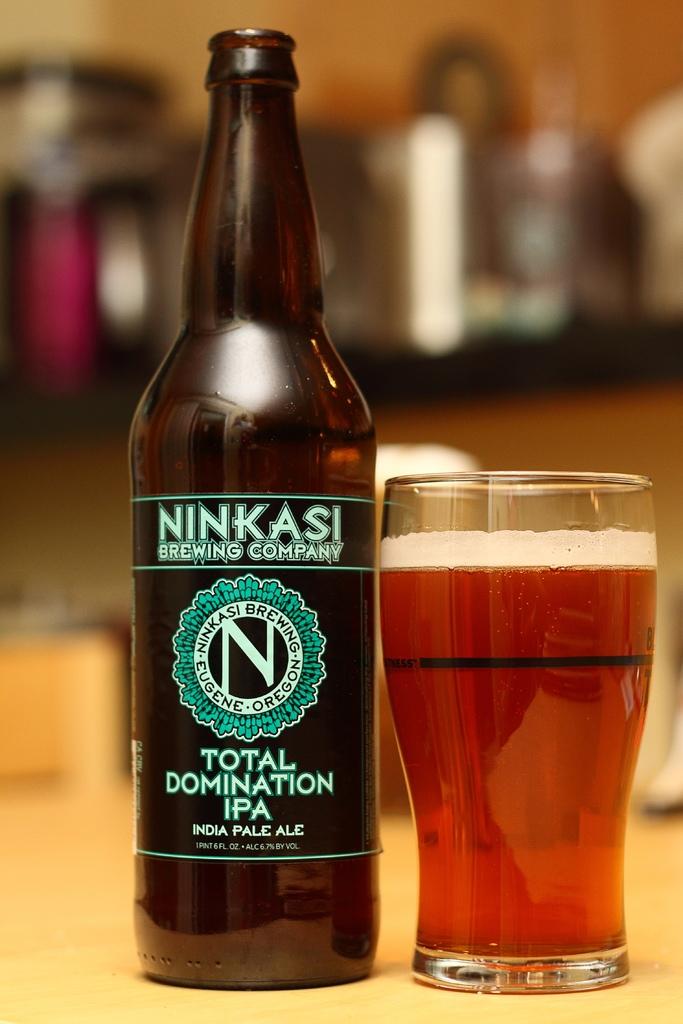What kind of beer is this?
Provide a succinct answer. Ninkasi. How many ounces is this beer?
Make the answer very short. 6. 